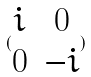Convert formula to latex. <formula><loc_0><loc_0><loc_500><loc_500>( \begin{matrix} i & 0 \\ 0 & - i \end{matrix} )</formula> 